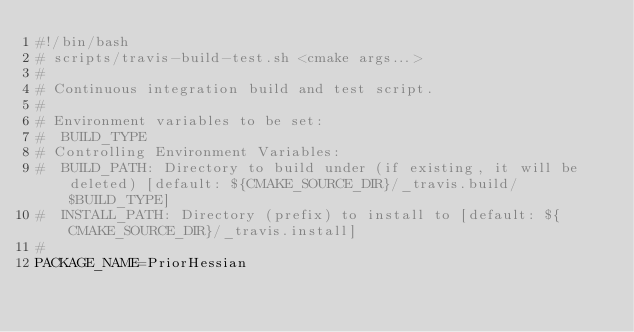<code> <loc_0><loc_0><loc_500><loc_500><_Bash_>#!/bin/bash
# scripts/travis-build-test.sh <cmake args...>
#
# Continuous integration build and test script.
#
# Environment variables to be set:
#  BUILD_TYPE
# Controlling Environment Variables:
#  BUILD_PATH: Directory to build under (if existing, it will be deleted) [default: ${CMAKE_SOURCE_DIR}/_travis.build/$BUILD_TYPE]
#  INSTALL_PATH: Directory (prefix) to install to [default: ${CMAKE_SOURCE_DIR}/_travis.install]
#
PACKAGE_NAME=PriorHessian</code> 